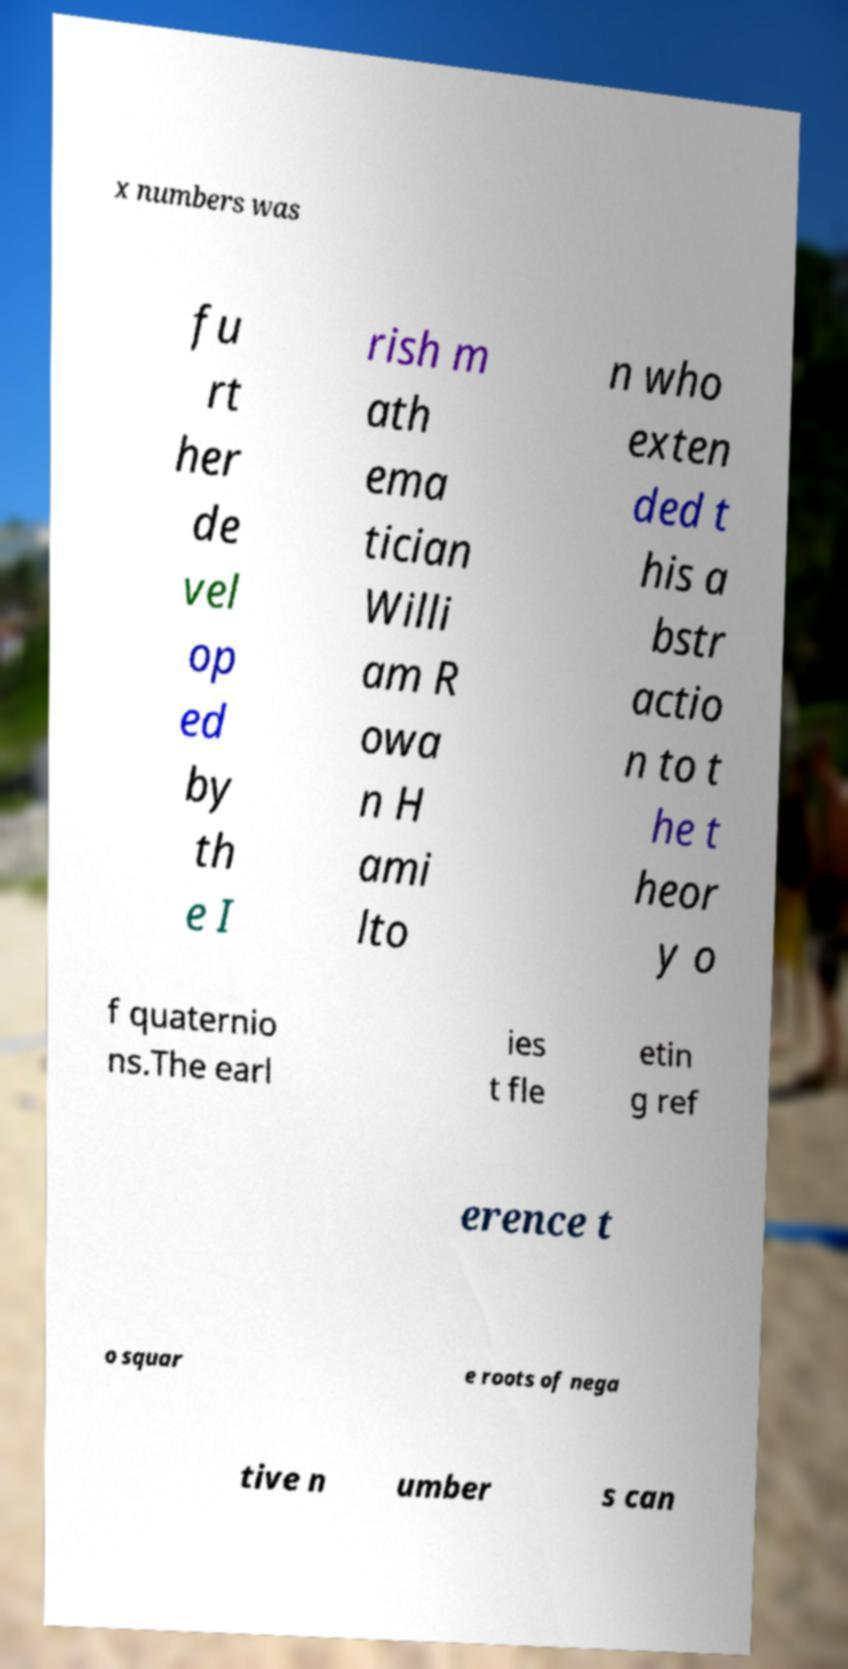Could you assist in decoding the text presented in this image and type it out clearly? x numbers was fu rt her de vel op ed by th e I rish m ath ema tician Willi am R owa n H ami lto n who exten ded t his a bstr actio n to t he t heor y o f quaternio ns.The earl ies t fle etin g ref erence t o squar e roots of nega tive n umber s can 